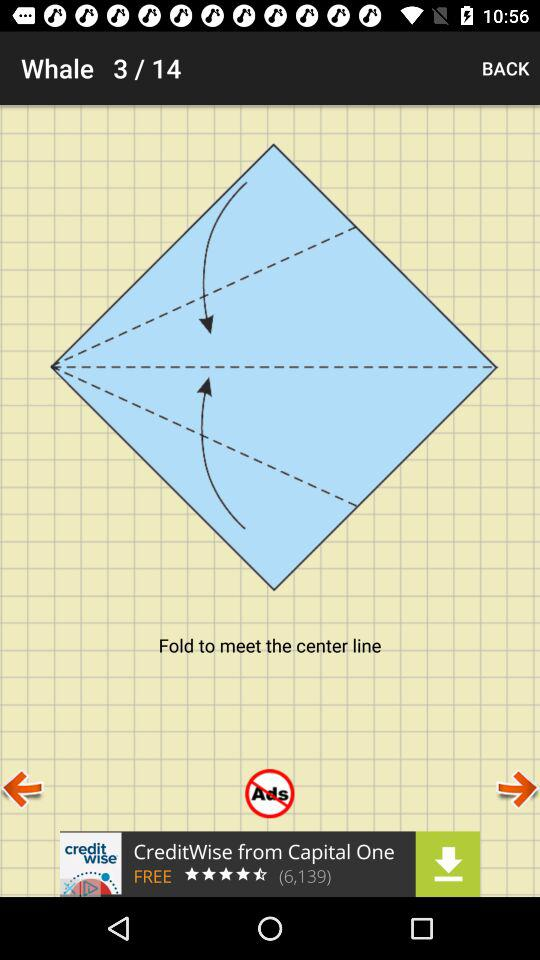What are image 4's instructions?
When the provided information is insufficient, respond with <no answer>. <no answer> 